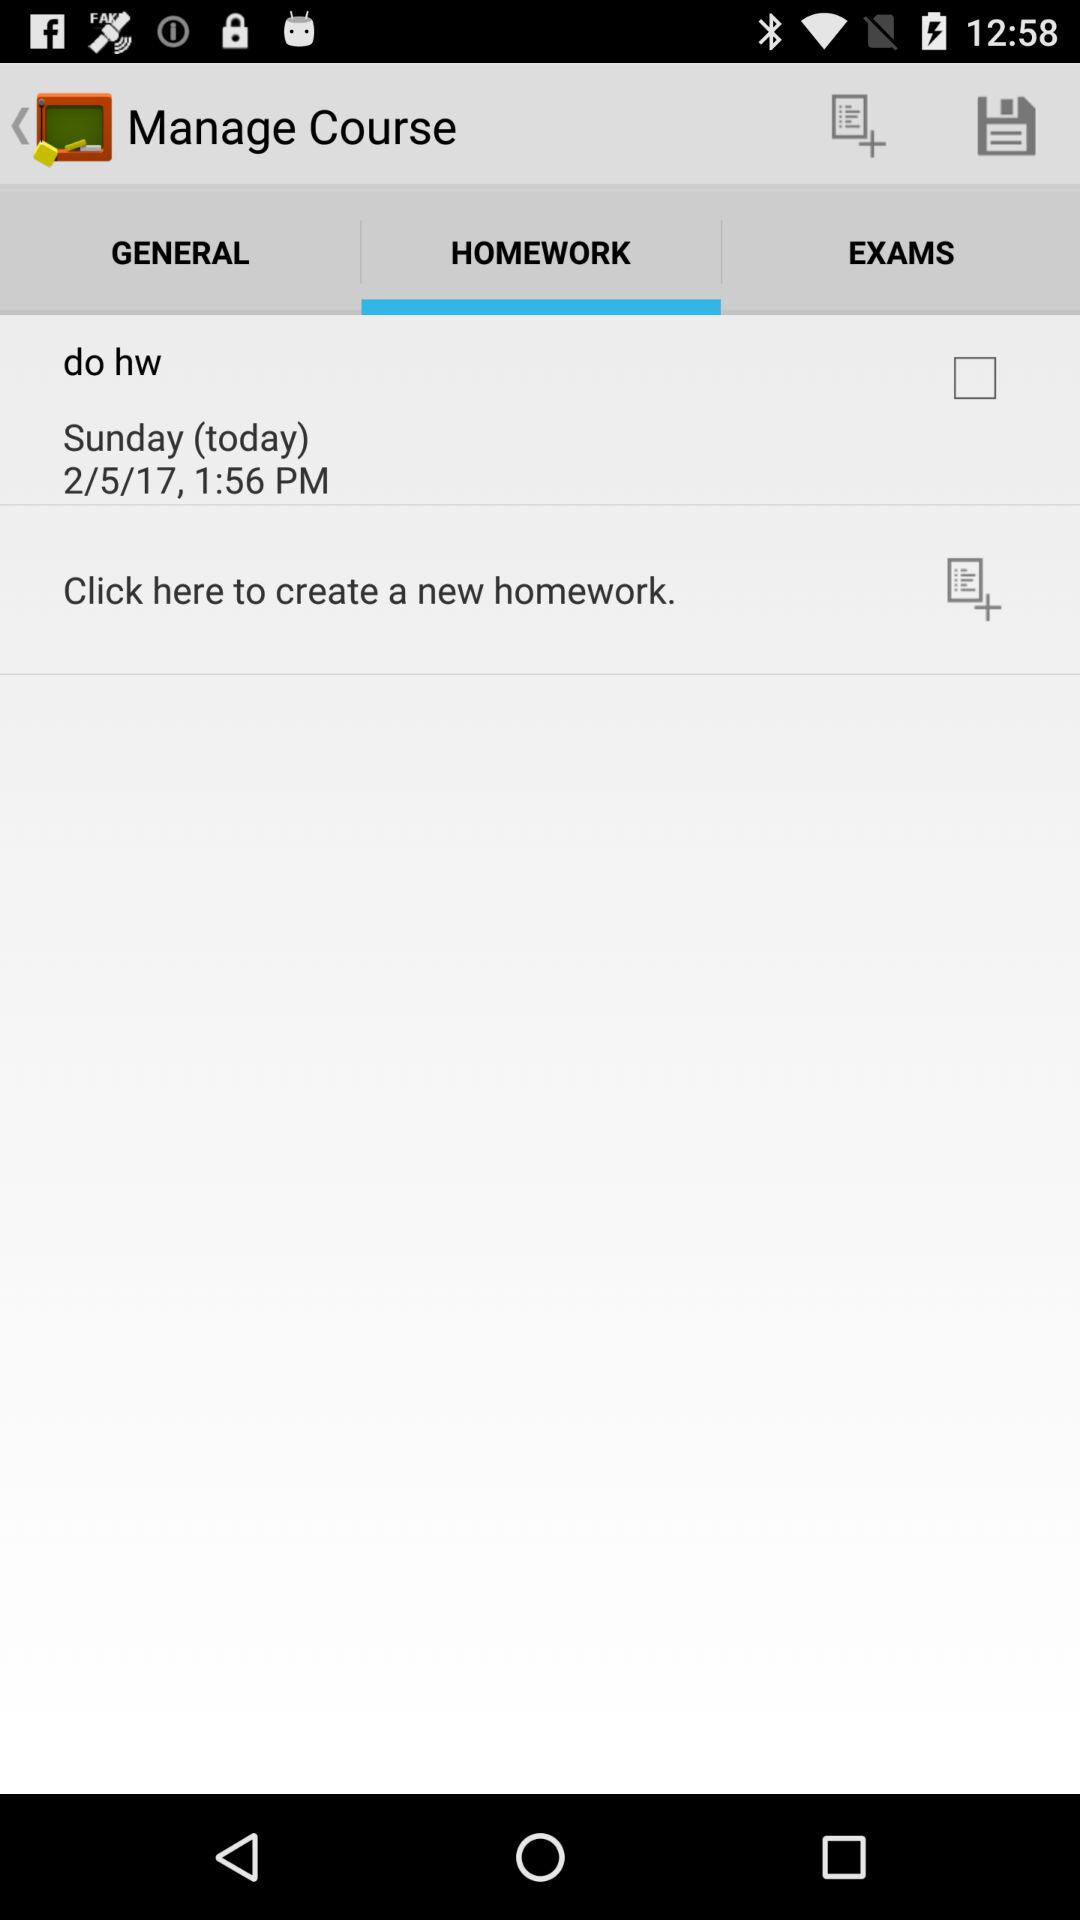What is the mentioned date? The mentioned date is Sunday, February 5, 2017. 